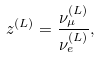<formula> <loc_0><loc_0><loc_500><loc_500>z ^ { ( L ) } = \frac { \nu ^ { ( L ) } _ { \mu } } { \nu ^ { ( L ) } _ { e } } ,</formula> 